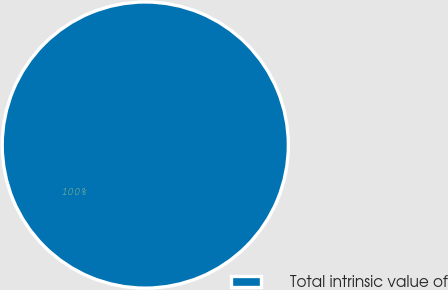Convert chart. <chart><loc_0><loc_0><loc_500><loc_500><pie_chart><fcel>Total intrinsic value of<nl><fcel>100.0%<nl></chart> 